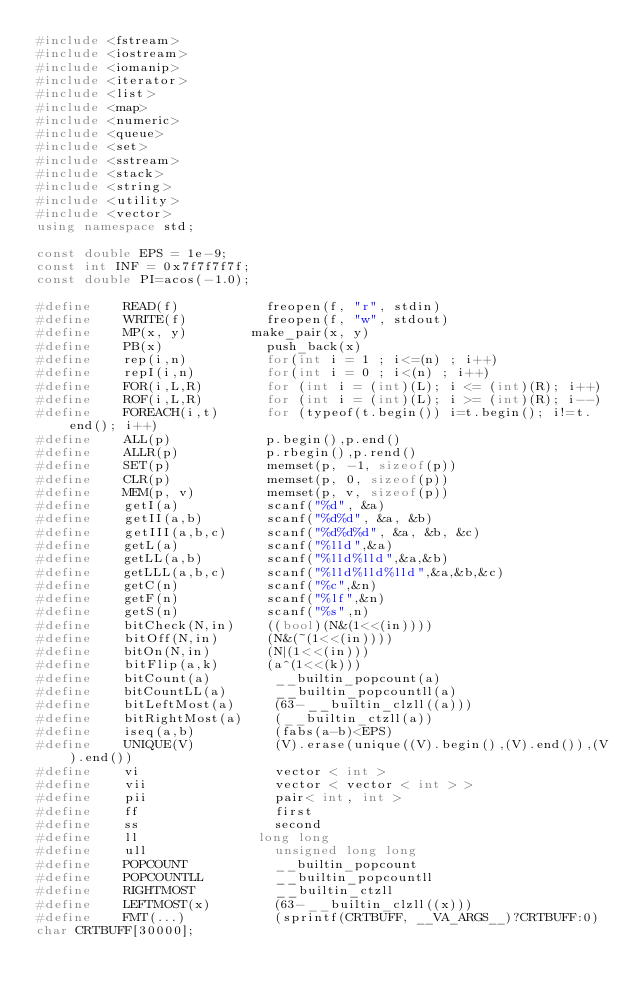Convert code to text. <code><loc_0><loc_0><loc_500><loc_500><_C++_>#include <fstream>
#include <iostream>
#include <iomanip>
#include <iterator>
#include <list>
#include <map>
#include <numeric>
#include <queue>
#include <set>
#include <sstream>
#include <stack>
#include <string>
#include <utility>
#include <vector>
using namespace std;

const double EPS = 1e-9;
const int INF = 0x7f7f7f7f;
const double PI=acos(-1.0);

#define    READ(f) 	         freopen(f, "r", stdin)
#define    WRITE(f)   	     freopen(f, "w", stdout)
#define    MP(x, y) 	     make_pair(x, y)
#define    PB(x)             push_back(x)
#define    rep(i,n)          for(int i = 1 ; i<=(n) ; i++)
#define    repI(i,n)         for(int i = 0 ; i<(n) ; i++)
#define    FOR(i,L,R) 	     for (int i = (int)(L); i <= (int)(R); i++)
#define    ROF(i,L,R) 	     for (int i = (int)(L); i >= (int)(R); i--)
#define    FOREACH(i,t)      for (typeof(t.begin()) i=t.begin(); i!=t.end(); i++)
#define    ALL(p) 	         p.begin(),p.end()
#define    ALLR(p) 	         p.rbegin(),p.rend()
#define    SET(p) 	         memset(p, -1, sizeof(p))
#define    CLR(p)            memset(p, 0, sizeof(p))
#define    MEM(p, v)         memset(p, v, sizeof(p))
#define    getI(a) 	         scanf("%d", &a)
#define    getII(a,b) 	     scanf("%d%d", &a, &b)
#define    getIII(a,b,c)     scanf("%d%d%d", &a, &b, &c)
#define    getL(a)           scanf("%lld",&a)
#define    getLL(a,b)        scanf("%lld%lld",&a,&b)
#define    getLLL(a,b,c)     scanf("%lld%lld%lld",&a,&b,&c)
#define    getC(n)           scanf("%c",&n)
#define    getF(n)           scanf("%lf",&n)
#define    getS(n)           scanf("%s",n)
#define    bitCheck(N,in)    ((bool)(N&(1<<(in))))
#define    bitOff(N,in)      (N&(~(1<<(in))))
#define    bitOn(N,in)       (N|(1<<(in)))
#define    bitFlip(a,k)      (a^(1<<(k)))
#define    bitCount(a)        __builtin_popcount(a)
#define    bitCountLL(a)      __builtin_popcountll(a)
#define    bitLeftMost(a)     (63-__builtin_clzll((a)))
#define    bitRightMost(a)    (__builtin_ctzll(a))
#define    iseq(a,b)          (fabs(a-b)<EPS)
#define    UNIQUE(V)          (V).erase(unique((V).begin(),(V).end()),(V).end())
#define    vi 	              vector < int >
#define    vii 	              vector < vector < int > >
#define    pii 	              pair< int, int >
#define    ff 	              first
#define    ss 	              second
#define    ll	              long long
#define    ull 	              unsigned long long
#define    POPCOUNT           __builtin_popcount
#define    POPCOUNTLL         __builtin_popcountll
#define    RIGHTMOST          __builtin_ctzll
#define    LEFTMOST(x)        (63-__builtin_clzll((x)))
#define    FMT(...)           (sprintf(CRTBUFF, __VA_ARGS__)?CRTBUFF:0)
char CRTBUFF[30000];
</code> 